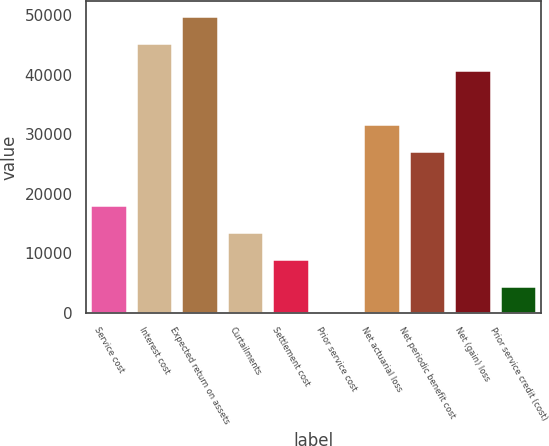<chart> <loc_0><loc_0><loc_500><loc_500><bar_chart><fcel>Service cost<fcel>Interest cost<fcel>Expected return on assets<fcel>Curtailments<fcel>Settlement cost<fcel>Prior service cost<fcel>Net actuarial loss<fcel>Net periodic benefit cost<fcel>Net (gain) loss<fcel>Prior service credit (cost)<nl><fcel>18115.6<fcel>45280<fcel>49807.4<fcel>13588.2<fcel>9060.8<fcel>6<fcel>31697.8<fcel>27170.4<fcel>40752.6<fcel>4533.4<nl></chart> 